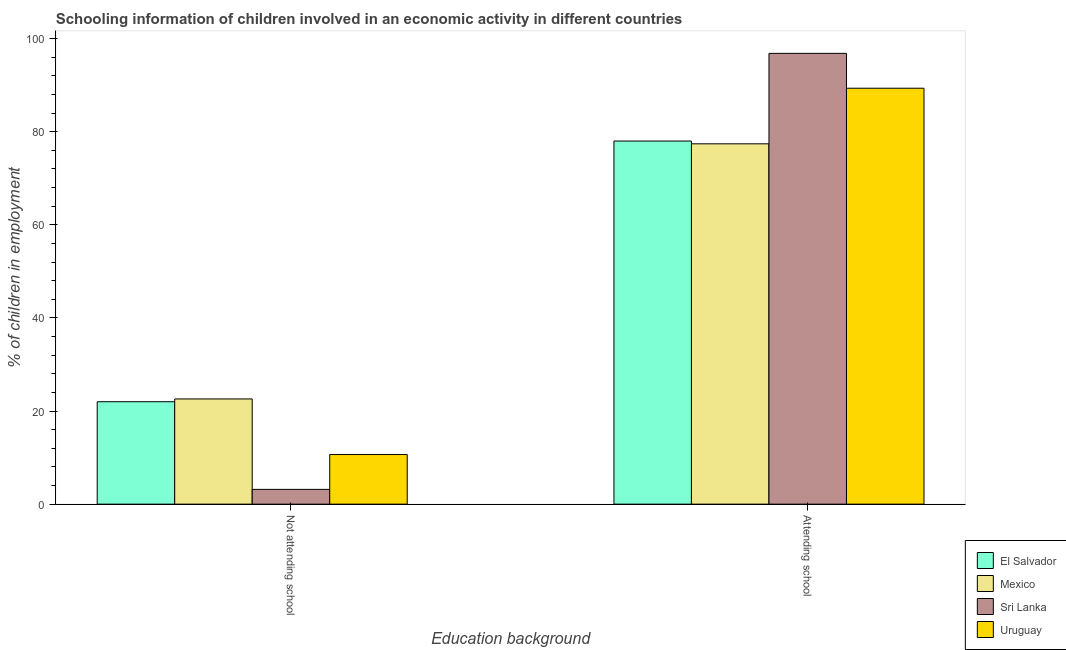How many different coloured bars are there?
Your answer should be very brief. 4. How many groups of bars are there?
Offer a terse response. 2. Are the number of bars per tick equal to the number of legend labels?
Your answer should be compact. Yes. Are the number of bars on each tick of the X-axis equal?
Ensure brevity in your answer.  Yes. How many bars are there on the 2nd tick from the left?
Provide a succinct answer. 4. What is the label of the 1st group of bars from the left?
Provide a succinct answer. Not attending school. What is the percentage of employed children who are not attending school in Mexico?
Offer a very short reply. 22.6. Across all countries, what is the maximum percentage of employed children who are not attending school?
Give a very brief answer. 22.6. Across all countries, what is the minimum percentage of employed children who are not attending school?
Provide a succinct answer. 3.17. In which country was the percentage of employed children who are attending school minimum?
Your response must be concise. Mexico. What is the total percentage of employed children who are not attending school in the graph?
Provide a succinct answer. 58.43. What is the difference between the percentage of employed children who are attending school in El Salvador and that in Uruguay?
Offer a terse response. -11.34. What is the difference between the percentage of employed children who are attending school in Mexico and the percentage of employed children who are not attending school in Sri Lanka?
Make the answer very short. 74.23. What is the average percentage of employed children who are attending school per country?
Ensure brevity in your answer.  85.39. What is the difference between the percentage of employed children who are attending school and percentage of employed children who are not attending school in Sri Lanka?
Keep it short and to the point. 93.66. What is the ratio of the percentage of employed children who are not attending school in Uruguay to that in Mexico?
Your answer should be compact. 0.47. Is the percentage of employed children who are not attending school in Mexico less than that in Uruguay?
Ensure brevity in your answer.  No. What does the 4th bar from the left in Attending school represents?
Ensure brevity in your answer.  Uruguay. What does the 2nd bar from the right in Not attending school represents?
Offer a terse response. Sri Lanka. How many bars are there?
Your answer should be compact. 8. Are all the bars in the graph horizontal?
Ensure brevity in your answer.  No. How many countries are there in the graph?
Give a very brief answer. 4. Are the values on the major ticks of Y-axis written in scientific E-notation?
Ensure brevity in your answer.  No. How many legend labels are there?
Offer a very short reply. 4. What is the title of the graph?
Provide a succinct answer. Schooling information of children involved in an economic activity in different countries. What is the label or title of the X-axis?
Your answer should be very brief. Education background. What is the label or title of the Y-axis?
Keep it short and to the point. % of children in employment. What is the % of children in employment of El Salvador in Not attending school?
Your answer should be very brief. 22. What is the % of children in employment in Mexico in Not attending school?
Offer a terse response. 22.6. What is the % of children in employment of Sri Lanka in Not attending school?
Provide a short and direct response. 3.17. What is the % of children in employment of Uruguay in Not attending school?
Offer a terse response. 10.66. What is the % of children in employment of El Salvador in Attending school?
Your answer should be compact. 78. What is the % of children in employment in Mexico in Attending school?
Give a very brief answer. 77.4. What is the % of children in employment in Sri Lanka in Attending school?
Offer a very short reply. 96.83. What is the % of children in employment of Uruguay in Attending school?
Your answer should be very brief. 89.34. Across all Education background, what is the maximum % of children in employment of El Salvador?
Keep it short and to the point. 78. Across all Education background, what is the maximum % of children in employment in Mexico?
Give a very brief answer. 77.4. Across all Education background, what is the maximum % of children in employment of Sri Lanka?
Offer a very short reply. 96.83. Across all Education background, what is the maximum % of children in employment of Uruguay?
Provide a succinct answer. 89.34. Across all Education background, what is the minimum % of children in employment in El Salvador?
Ensure brevity in your answer.  22. Across all Education background, what is the minimum % of children in employment of Mexico?
Keep it short and to the point. 22.6. Across all Education background, what is the minimum % of children in employment of Sri Lanka?
Offer a terse response. 3.17. Across all Education background, what is the minimum % of children in employment of Uruguay?
Give a very brief answer. 10.66. What is the total % of children in employment of Sri Lanka in the graph?
Offer a very short reply. 100. What is the difference between the % of children in employment of El Salvador in Not attending school and that in Attending school?
Keep it short and to the point. -56. What is the difference between the % of children in employment of Mexico in Not attending school and that in Attending school?
Make the answer very short. -54.8. What is the difference between the % of children in employment of Sri Lanka in Not attending school and that in Attending school?
Make the answer very short. -93.66. What is the difference between the % of children in employment of Uruguay in Not attending school and that in Attending school?
Ensure brevity in your answer.  -78.68. What is the difference between the % of children in employment in El Salvador in Not attending school and the % of children in employment in Mexico in Attending school?
Keep it short and to the point. -55.4. What is the difference between the % of children in employment in El Salvador in Not attending school and the % of children in employment in Sri Lanka in Attending school?
Provide a succinct answer. -74.83. What is the difference between the % of children in employment in El Salvador in Not attending school and the % of children in employment in Uruguay in Attending school?
Your answer should be compact. -67.34. What is the difference between the % of children in employment of Mexico in Not attending school and the % of children in employment of Sri Lanka in Attending school?
Your answer should be very brief. -74.23. What is the difference between the % of children in employment of Mexico in Not attending school and the % of children in employment of Uruguay in Attending school?
Make the answer very short. -66.74. What is the difference between the % of children in employment of Sri Lanka in Not attending school and the % of children in employment of Uruguay in Attending school?
Make the answer very short. -86.17. What is the average % of children in employment of Uruguay per Education background?
Ensure brevity in your answer.  50. What is the difference between the % of children in employment in El Salvador and % of children in employment in Sri Lanka in Not attending school?
Give a very brief answer. 18.83. What is the difference between the % of children in employment of El Salvador and % of children in employment of Uruguay in Not attending school?
Make the answer very short. 11.34. What is the difference between the % of children in employment of Mexico and % of children in employment of Sri Lanka in Not attending school?
Keep it short and to the point. 19.43. What is the difference between the % of children in employment in Mexico and % of children in employment in Uruguay in Not attending school?
Offer a terse response. 11.94. What is the difference between the % of children in employment of Sri Lanka and % of children in employment of Uruguay in Not attending school?
Offer a very short reply. -7.49. What is the difference between the % of children in employment of El Salvador and % of children in employment of Mexico in Attending school?
Make the answer very short. 0.6. What is the difference between the % of children in employment in El Salvador and % of children in employment in Sri Lanka in Attending school?
Make the answer very short. -18.83. What is the difference between the % of children in employment in El Salvador and % of children in employment in Uruguay in Attending school?
Your answer should be very brief. -11.34. What is the difference between the % of children in employment in Mexico and % of children in employment in Sri Lanka in Attending school?
Keep it short and to the point. -19.43. What is the difference between the % of children in employment in Mexico and % of children in employment in Uruguay in Attending school?
Your answer should be compact. -11.94. What is the difference between the % of children in employment in Sri Lanka and % of children in employment in Uruguay in Attending school?
Keep it short and to the point. 7.49. What is the ratio of the % of children in employment in El Salvador in Not attending school to that in Attending school?
Offer a terse response. 0.28. What is the ratio of the % of children in employment of Mexico in Not attending school to that in Attending school?
Your answer should be very brief. 0.29. What is the ratio of the % of children in employment in Sri Lanka in Not attending school to that in Attending school?
Offer a terse response. 0.03. What is the ratio of the % of children in employment in Uruguay in Not attending school to that in Attending school?
Keep it short and to the point. 0.12. What is the difference between the highest and the second highest % of children in employment in Mexico?
Make the answer very short. 54.8. What is the difference between the highest and the second highest % of children in employment of Sri Lanka?
Offer a terse response. 93.66. What is the difference between the highest and the second highest % of children in employment of Uruguay?
Your response must be concise. 78.68. What is the difference between the highest and the lowest % of children in employment of El Salvador?
Provide a succinct answer. 56. What is the difference between the highest and the lowest % of children in employment of Mexico?
Provide a succinct answer. 54.8. What is the difference between the highest and the lowest % of children in employment of Sri Lanka?
Provide a succinct answer. 93.66. What is the difference between the highest and the lowest % of children in employment of Uruguay?
Make the answer very short. 78.68. 